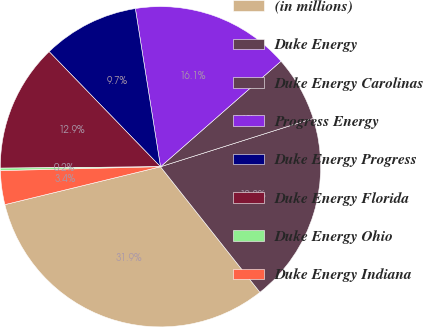Convert chart to OTSL. <chart><loc_0><loc_0><loc_500><loc_500><pie_chart><fcel>(in millions)<fcel>Duke Energy<fcel>Duke Energy Carolinas<fcel>Progress Energy<fcel>Duke Energy Progress<fcel>Duke Energy Florida<fcel>Duke Energy Ohio<fcel>Duke Energy Indiana<nl><fcel>31.86%<fcel>19.22%<fcel>6.57%<fcel>16.06%<fcel>9.73%<fcel>12.9%<fcel>0.25%<fcel>3.41%<nl></chart> 